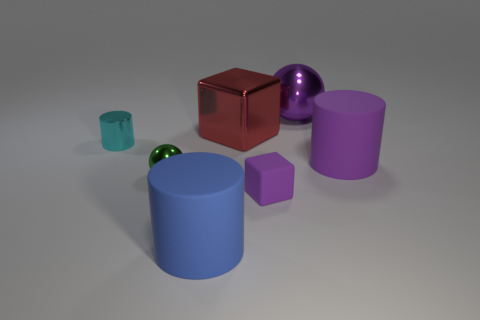Subtract all large purple cylinders. How many cylinders are left? 2 Add 1 big purple matte cylinders. How many objects exist? 8 Subtract all balls. How many objects are left? 5 Subtract 1 blocks. How many blocks are left? 1 Add 2 matte objects. How many matte objects are left? 5 Add 1 purple shiny objects. How many purple shiny objects exist? 2 Subtract 0 gray spheres. How many objects are left? 7 Subtract all blue blocks. Subtract all blue spheres. How many blocks are left? 2 Subtract all cyan matte blocks. Subtract all purple things. How many objects are left? 4 